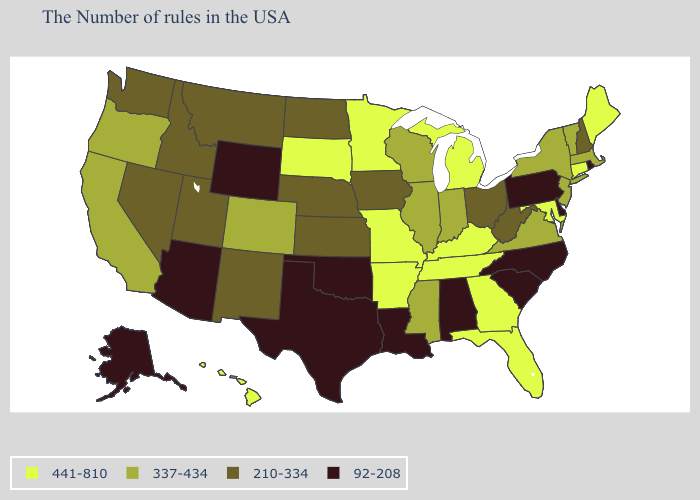What is the value of Hawaii?
Keep it brief. 441-810. Name the states that have a value in the range 337-434?
Quick response, please. Massachusetts, Vermont, New York, New Jersey, Virginia, Indiana, Wisconsin, Illinois, Mississippi, Colorado, California, Oregon. Does Hawaii have the lowest value in the USA?
Quick response, please. No. Which states have the highest value in the USA?
Write a very short answer. Maine, Connecticut, Maryland, Florida, Georgia, Michigan, Kentucky, Tennessee, Missouri, Arkansas, Minnesota, South Dakota, Hawaii. What is the value of Utah?
Give a very brief answer. 210-334. Name the states that have a value in the range 210-334?
Give a very brief answer. New Hampshire, West Virginia, Ohio, Iowa, Kansas, Nebraska, North Dakota, New Mexico, Utah, Montana, Idaho, Nevada, Washington. Which states have the lowest value in the South?
Short answer required. Delaware, North Carolina, South Carolina, Alabama, Louisiana, Oklahoma, Texas. How many symbols are there in the legend?
Give a very brief answer. 4. What is the value of Pennsylvania?
Keep it brief. 92-208. Does Alaska have the lowest value in the West?
Be succinct. Yes. Name the states that have a value in the range 337-434?
Write a very short answer. Massachusetts, Vermont, New York, New Jersey, Virginia, Indiana, Wisconsin, Illinois, Mississippi, Colorado, California, Oregon. Name the states that have a value in the range 210-334?
Write a very short answer. New Hampshire, West Virginia, Ohio, Iowa, Kansas, Nebraska, North Dakota, New Mexico, Utah, Montana, Idaho, Nevada, Washington. What is the value of Ohio?
Keep it brief. 210-334. Name the states that have a value in the range 337-434?
Give a very brief answer. Massachusetts, Vermont, New York, New Jersey, Virginia, Indiana, Wisconsin, Illinois, Mississippi, Colorado, California, Oregon. Name the states that have a value in the range 210-334?
Write a very short answer. New Hampshire, West Virginia, Ohio, Iowa, Kansas, Nebraska, North Dakota, New Mexico, Utah, Montana, Idaho, Nevada, Washington. 